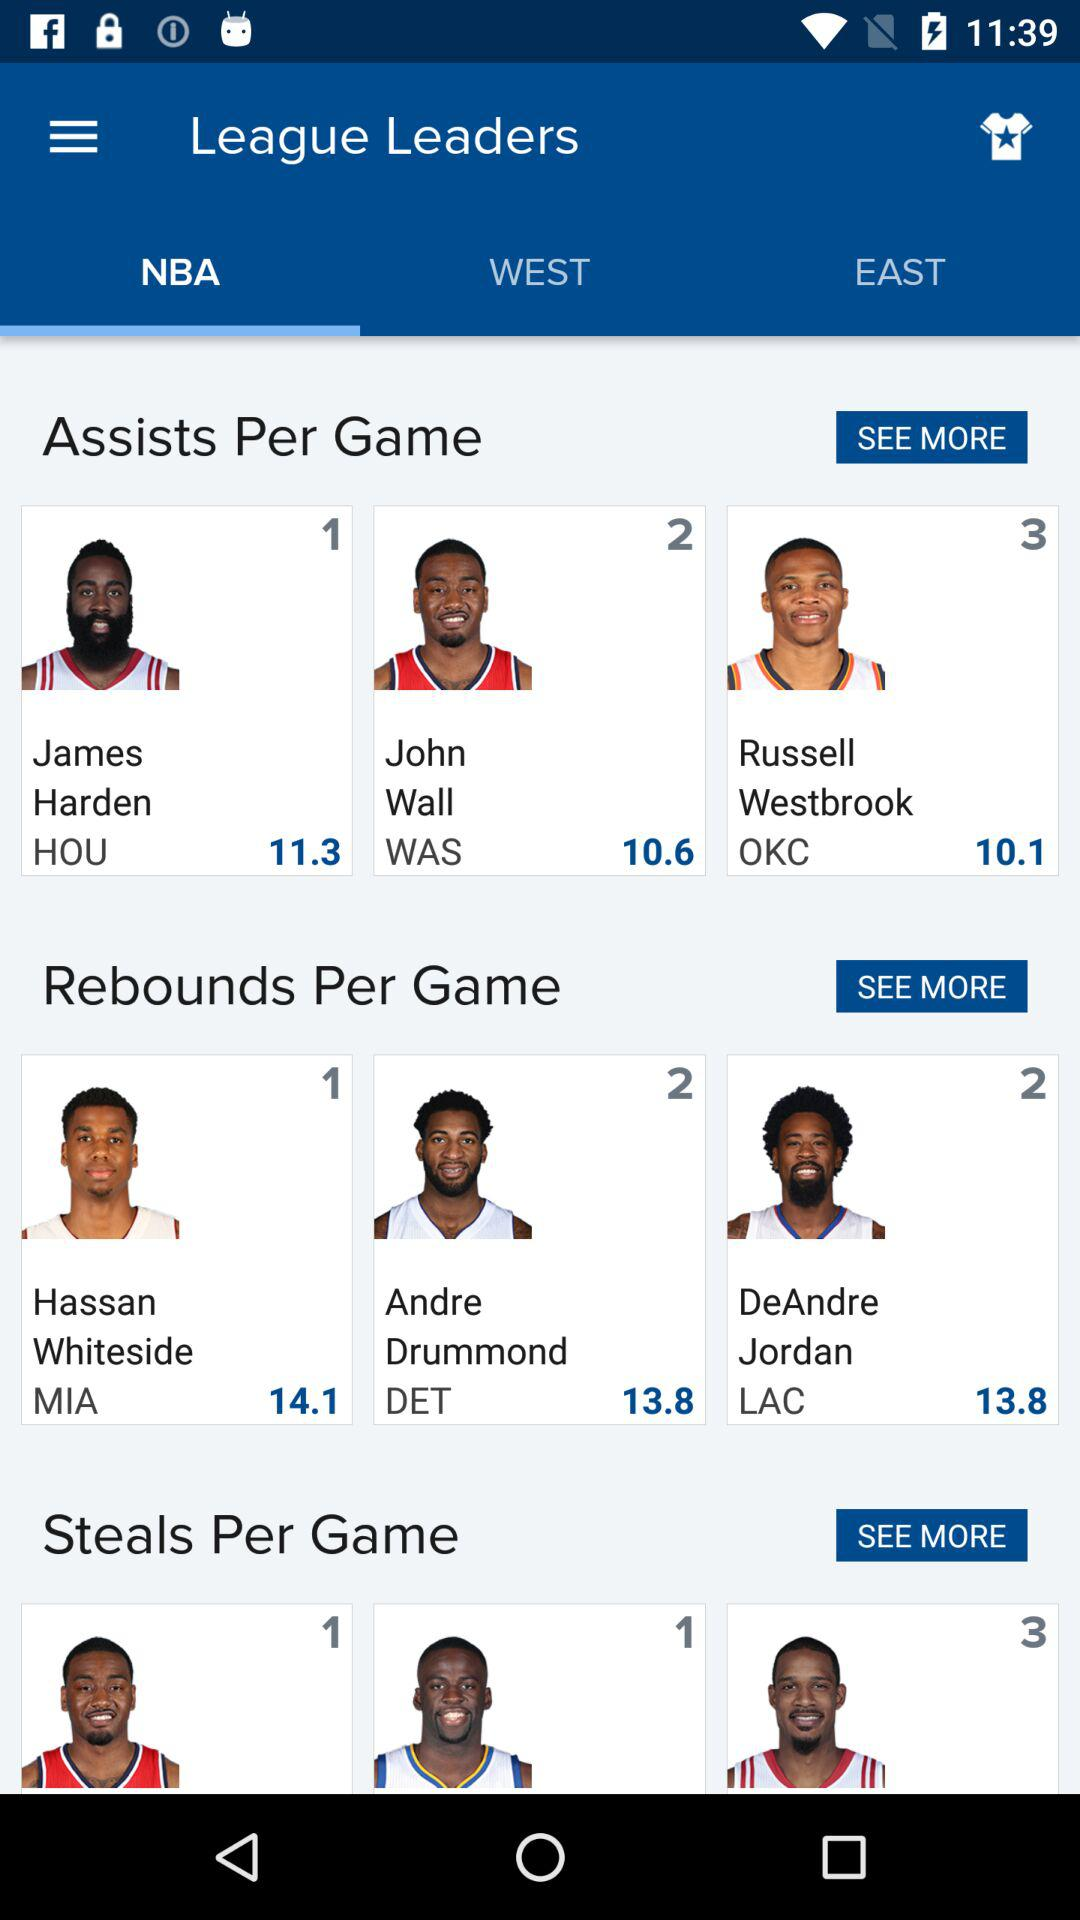What are the player names in "Assists Per Game"? The player names in "Assists Per Game" are James Harden, John Wall and Russell Westbrook. 